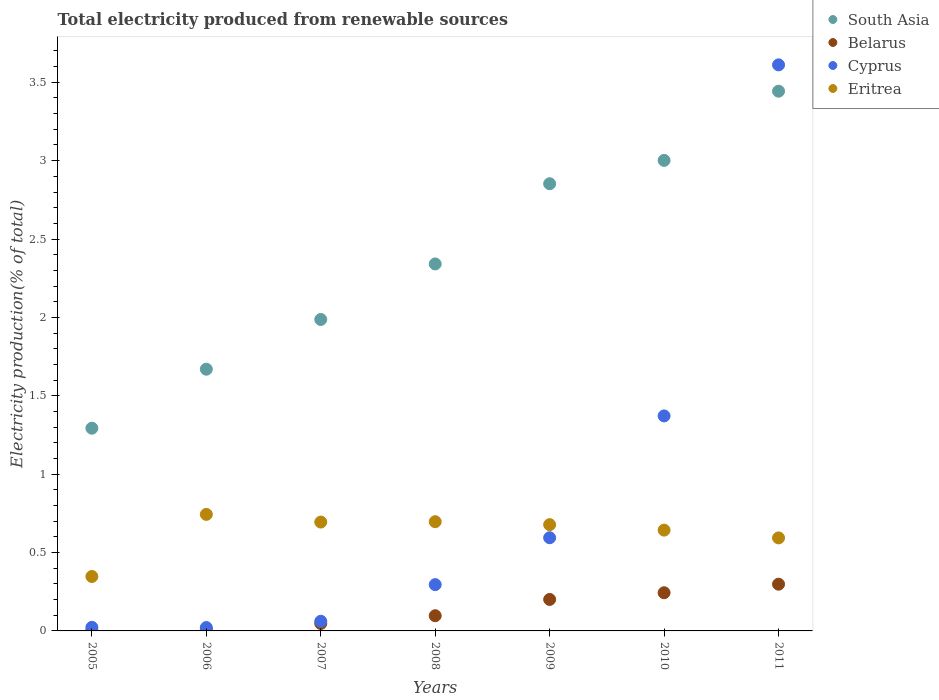How many different coloured dotlines are there?
Offer a terse response. 4. What is the total electricity produced in Eritrea in 2008?
Your answer should be compact. 0.7. Across all years, what is the maximum total electricity produced in Eritrea?
Your answer should be compact. 0.74. Across all years, what is the minimum total electricity produced in Cyprus?
Offer a very short reply. 0.02. In which year was the total electricity produced in South Asia minimum?
Your answer should be very brief. 2005. What is the total total electricity produced in Cyprus in the graph?
Provide a short and direct response. 5.98. What is the difference between the total electricity produced in Belarus in 2008 and that in 2010?
Provide a succinct answer. -0.15. What is the difference between the total electricity produced in Eritrea in 2006 and the total electricity produced in Belarus in 2005?
Your answer should be compact. 0.74. What is the average total electricity produced in Belarus per year?
Your response must be concise. 0.13. In the year 2007, what is the difference between the total electricity produced in Cyprus and total electricity produced in South Asia?
Keep it short and to the point. -1.93. What is the ratio of the total electricity produced in Cyprus in 2006 to that in 2011?
Make the answer very short. 0.01. What is the difference between the highest and the second highest total electricity produced in South Asia?
Give a very brief answer. 0.44. What is the difference between the highest and the lowest total electricity produced in South Asia?
Offer a terse response. 2.15. Does the total electricity produced in Belarus monotonically increase over the years?
Offer a terse response. Yes. Is the total electricity produced in Belarus strictly greater than the total electricity produced in Cyprus over the years?
Make the answer very short. No. How many dotlines are there?
Make the answer very short. 4. How many years are there in the graph?
Provide a succinct answer. 7. What is the title of the graph?
Offer a terse response. Total electricity produced from renewable sources. What is the label or title of the Y-axis?
Offer a very short reply. Electricity production(% of total). What is the Electricity production(% of total) in South Asia in 2005?
Your answer should be very brief. 1.29. What is the Electricity production(% of total) of Belarus in 2005?
Ensure brevity in your answer.  0. What is the Electricity production(% of total) in Cyprus in 2005?
Provide a short and direct response. 0.02. What is the Electricity production(% of total) of Eritrea in 2005?
Your answer should be very brief. 0.35. What is the Electricity production(% of total) in South Asia in 2006?
Offer a very short reply. 1.67. What is the Electricity production(% of total) in Belarus in 2006?
Your response must be concise. 0.01. What is the Electricity production(% of total) of Cyprus in 2006?
Provide a short and direct response. 0.02. What is the Electricity production(% of total) of Eritrea in 2006?
Offer a very short reply. 0.74. What is the Electricity production(% of total) in South Asia in 2007?
Offer a terse response. 1.99. What is the Electricity production(% of total) in Belarus in 2007?
Your answer should be very brief. 0.05. What is the Electricity production(% of total) of Cyprus in 2007?
Offer a terse response. 0.06. What is the Electricity production(% of total) of Eritrea in 2007?
Keep it short and to the point. 0.69. What is the Electricity production(% of total) in South Asia in 2008?
Offer a very short reply. 2.34. What is the Electricity production(% of total) in Belarus in 2008?
Provide a succinct answer. 0.1. What is the Electricity production(% of total) of Cyprus in 2008?
Ensure brevity in your answer.  0.3. What is the Electricity production(% of total) of Eritrea in 2008?
Your answer should be compact. 0.7. What is the Electricity production(% of total) in South Asia in 2009?
Ensure brevity in your answer.  2.85. What is the Electricity production(% of total) of Belarus in 2009?
Your answer should be very brief. 0.2. What is the Electricity production(% of total) of Cyprus in 2009?
Provide a succinct answer. 0.59. What is the Electricity production(% of total) of Eritrea in 2009?
Make the answer very short. 0.68. What is the Electricity production(% of total) in South Asia in 2010?
Your answer should be very brief. 3. What is the Electricity production(% of total) in Belarus in 2010?
Give a very brief answer. 0.24. What is the Electricity production(% of total) in Cyprus in 2010?
Give a very brief answer. 1.37. What is the Electricity production(% of total) in Eritrea in 2010?
Provide a succinct answer. 0.64. What is the Electricity production(% of total) of South Asia in 2011?
Ensure brevity in your answer.  3.44. What is the Electricity production(% of total) in Belarus in 2011?
Your answer should be very brief. 0.3. What is the Electricity production(% of total) of Cyprus in 2011?
Your answer should be very brief. 3.61. What is the Electricity production(% of total) of Eritrea in 2011?
Provide a succinct answer. 0.59. Across all years, what is the maximum Electricity production(% of total) of South Asia?
Make the answer very short. 3.44. Across all years, what is the maximum Electricity production(% of total) of Belarus?
Offer a very short reply. 0.3. Across all years, what is the maximum Electricity production(% of total) in Cyprus?
Your answer should be compact. 3.61. Across all years, what is the maximum Electricity production(% of total) in Eritrea?
Your answer should be compact. 0.74. Across all years, what is the minimum Electricity production(% of total) of South Asia?
Make the answer very short. 1.29. Across all years, what is the minimum Electricity production(% of total) of Belarus?
Ensure brevity in your answer.  0. Across all years, what is the minimum Electricity production(% of total) in Cyprus?
Your response must be concise. 0.02. Across all years, what is the minimum Electricity production(% of total) in Eritrea?
Offer a terse response. 0.35. What is the total Electricity production(% of total) in South Asia in the graph?
Ensure brevity in your answer.  16.59. What is the total Electricity production(% of total) in Belarus in the graph?
Your response must be concise. 0.9. What is the total Electricity production(% of total) of Cyprus in the graph?
Make the answer very short. 5.98. What is the total Electricity production(% of total) of Eritrea in the graph?
Ensure brevity in your answer.  4.4. What is the difference between the Electricity production(% of total) in South Asia in 2005 and that in 2006?
Make the answer very short. -0.38. What is the difference between the Electricity production(% of total) in Belarus in 2005 and that in 2006?
Offer a terse response. -0.01. What is the difference between the Electricity production(% of total) of Cyprus in 2005 and that in 2006?
Your response must be concise. 0. What is the difference between the Electricity production(% of total) of Eritrea in 2005 and that in 2006?
Keep it short and to the point. -0.4. What is the difference between the Electricity production(% of total) of South Asia in 2005 and that in 2007?
Your answer should be compact. -0.69. What is the difference between the Electricity production(% of total) in Belarus in 2005 and that in 2007?
Provide a short and direct response. -0.04. What is the difference between the Electricity production(% of total) in Cyprus in 2005 and that in 2007?
Ensure brevity in your answer.  -0.04. What is the difference between the Electricity production(% of total) of Eritrea in 2005 and that in 2007?
Provide a short and direct response. -0.35. What is the difference between the Electricity production(% of total) in South Asia in 2005 and that in 2008?
Offer a terse response. -1.05. What is the difference between the Electricity production(% of total) of Belarus in 2005 and that in 2008?
Ensure brevity in your answer.  -0.09. What is the difference between the Electricity production(% of total) of Cyprus in 2005 and that in 2008?
Offer a terse response. -0.27. What is the difference between the Electricity production(% of total) of Eritrea in 2005 and that in 2008?
Your answer should be compact. -0.35. What is the difference between the Electricity production(% of total) of South Asia in 2005 and that in 2009?
Make the answer very short. -1.56. What is the difference between the Electricity production(% of total) in Belarus in 2005 and that in 2009?
Give a very brief answer. -0.2. What is the difference between the Electricity production(% of total) in Cyprus in 2005 and that in 2009?
Offer a very short reply. -0.57. What is the difference between the Electricity production(% of total) in Eritrea in 2005 and that in 2009?
Provide a succinct answer. -0.33. What is the difference between the Electricity production(% of total) in South Asia in 2005 and that in 2010?
Keep it short and to the point. -1.71. What is the difference between the Electricity production(% of total) of Belarus in 2005 and that in 2010?
Ensure brevity in your answer.  -0.24. What is the difference between the Electricity production(% of total) of Cyprus in 2005 and that in 2010?
Provide a short and direct response. -1.35. What is the difference between the Electricity production(% of total) of Eritrea in 2005 and that in 2010?
Your answer should be very brief. -0.3. What is the difference between the Electricity production(% of total) of South Asia in 2005 and that in 2011?
Provide a succinct answer. -2.15. What is the difference between the Electricity production(% of total) in Belarus in 2005 and that in 2011?
Make the answer very short. -0.29. What is the difference between the Electricity production(% of total) of Cyprus in 2005 and that in 2011?
Your response must be concise. -3.59. What is the difference between the Electricity production(% of total) in Eritrea in 2005 and that in 2011?
Your answer should be compact. -0.25. What is the difference between the Electricity production(% of total) in South Asia in 2006 and that in 2007?
Offer a very short reply. -0.32. What is the difference between the Electricity production(% of total) in Belarus in 2006 and that in 2007?
Offer a very short reply. -0.04. What is the difference between the Electricity production(% of total) in Cyprus in 2006 and that in 2007?
Offer a terse response. -0.04. What is the difference between the Electricity production(% of total) of Eritrea in 2006 and that in 2007?
Ensure brevity in your answer.  0.05. What is the difference between the Electricity production(% of total) in South Asia in 2006 and that in 2008?
Provide a succinct answer. -0.67. What is the difference between the Electricity production(% of total) of Belarus in 2006 and that in 2008?
Make the answer very short. -0.09. What is the difference between the Electricity production(% of total) in Cyprus in 2006 and that in 2008?
Ensure brevity in your answer.  -0.27. What is the difference between the Electricity production(% of total) in Eritrea in 2006 and that in 2008?
Offer a very short reply. 0.05. What is the difference between the Electricity production(% of total) in South Asia in 2006 and that in 2009?
Ensure brevity in your answer.  -1.18. What is the difference between the Electricity production(% of total) in Belarus in 2006 and that in 2009?
Your response must be concise. -0.19. What is the difference between the Electricity production(% of total) of Cyprus in 2006 and that in 2009?
Your answer should be very brief. -0.57. What is the difference between the Electricity production(% of total) in Eritrea in 2006 and that in 2009?
Your response must be concise. 0.07. What is the difference between the Electricity production(% of total) of South Asia in 2006 and that in 2010?
Ensure brevity in your answer.  -1.33. What is the difference between the Electricity production(% of total) in Belarus in 2006 and that in 2010?
Offer a very short reply. -0.23. What is the difference between the Electricity production(% of total) in Cyprus in 2006 and that in 2010?
Your answer should be compact. -1.35. What is the difference between the Electricity production(% of total) of Eritrea in 2006 and that in 2010?
Provide a succinct answer. 0.1. What is the difference between the Electricity production(% of total) of South Asia in 2006 and that in 2011?
Keep it short and to the point. -1.77. What is the difference between the Electricity production(% of total) in Belarus in 2006 and that in 2011?
Offer a very short reply. -0.29. What is the difference between the Electricity production(% of total) of Cyprus in 2006 and that in 2011?
Offer a very short reply. -3.59. What is the difference between the Electricity production(% of total) in Eritrea in 2006 and that in 2011?
Your response must be concise. 0.15. What is the difference between the Electricity production(% of total) in South Asia in 2007 and that in 2008?
Make the answer very short. -0.35. What is the difference between the Electricity production(% of total) of Belarus in 2007 and that in 2008?
Give a very brief answer. -0.05. What is the difference between the Electricity production(% of total) of Cyprus in 2007 and that in 2008?
Your answer should be compact. -0.23. What is the difference between the Electricity production(% of total) in Eritrea in 2007 and that in 2008?
Your response must be concise. -0. What is the difference between the Electricity production(% of total) in South Asia in 2007 and that in 2009?
Offer a very short reply. -0.87. What is the difference between the Electricity production(% of total) of Belarus in 2007 and that in 2009?
Give a very brief answer. -0.15. What is the difference between the Electricity production(% of total) in Cyprus in 2007 and that in 2009?
Keep it short and to the point. -0.53. What is the difference between the Electricity production(% of total) in Eritrea in 2007 and that in 2009?
Provide a succinct answer. 0.02. What is the difference between the Electricity production(% of total) in South Asia in 2007 and that in 2010?
Your answer should be compact. -1.01. What is the difference between the Electricity production(% of total) of Belarus in 2007 and that in 2010?
Make the answer very short. -0.2. What is the difference between the Electricity production(% of total) in Cyprus in 2007 and that in 2010?
Your answer should be very brief. -1.31. What is the difference between the Electricity production(% of total) of Eritrea in 2007 and that in 2010?
Offer a very short reply. 0.05. What is the difference between the Electricity production(% of total) of South Asia in 2007 and that in 2011?
Offer a very short reply. -1.46. What is the difference between the Electricity production(% of total) in Belarus in 2007 and that in 2011?
Your response must be concise. -0.25. What is the difference between the Electricity production(% of total) in Cyprus in 2007 and that in 2011?
Make the answer very short. -3.55. What is the difference between the Electricity production(% of total) of Eritrea in 2007 and that in 2011?
Keep it short and to the point. 0.1. What is the difference between the Electricity production(% of total) in South Asia in 2008 and that in 2009?
Ensure brevity in your answer.  -0.51. What is the difference between the Electricity production(% of total) in Belarus in 2008 and that in 2009?
Your answer should be very brief. -0.1. What is the difference between the Electricity production(% of total) of Cyprus in 2008 and that in 2009?
Your answer should be compact. -0.3. What is the difference between the Electricity production(% of total) in Eritrea in 2008 and that in 2009?
Offer a terse response. 0.02. What is the difference between the Electricity production(% of total) of South Asia in 2008 and that in 2010?
Your answer should be compact. -0.66. What is the difference between the Electricity production(% of total) in Belarus in 2008 and that in 2010?
Your answer should be very brief. -0.15. What is the difference between the Electricity production(% of total) of Cyprus in 2008 and that in 2010?
Your answer should be very brief. -1.08. What is the difference between the Electricity production(% of total) in Eritrea in 2008 and that in 2010?
Make the answer very short. 0.05. What is the difference between the Electricity production(% of total) of South Asia in 2008 and that in 2011?
Provide a short and direct response. -1.1. What is the difference between the Electricity production(% of total) in Belarus in 2008 and that in 2011?
Make the answer very short. -0.2. What is the difference between the Electricity production(% of total) of Cyprus in 2008 and that in 2011?
Provide a short and direct response. -3.32. What is the difference between the Electricity production(% of total) of Eritrea in 2008 and that in 2011?
Your response must be concise. 0.1. What is the difference between the Electricity production(% of total) of South Asia in 2009 and that in 2010?
Provide a short and direct response. -0.15. What is the difference between the Electricity production(% of total) of Belarus in 2009 and that in 2010?
Provide a succinct answer. -0.04. What is the difference between the Electricity production(% of total) in Cyprus in 2009 and that in 2010?
Give a very brief answer. -0.78. What is the difference between the Electricity production(% of total) of Eritrea in 2009 and that in 2010?
Provide a succinct answer. 0.03. What is the difference between the Electricity production(% of total) of South Asia in 2009 and that in 2011?
Make the answer very short. -0.59. What is the difference between the Electricity production(% of total) in Belarus in 2009 and that in 2011?
Offer a terse response. -0.1. What is the difference between the Electricity production(% of total) of Cyprus in 2009 and that in 2011?
Give a very brief answer. -3.02. What is the difference between the Electricity production(% of total) in Eritrea in 2009 and that in 2011?
Give a very brief answer. 0.08. What is the difference between the Electricity production(% of total) of South Asia in 2010 and that in 2011?
Your answer should be very brief. -0.44. What is the difference between the Electricity production(% of total) in Belarus in 2010 and that in 2011?
Provide a succinct answer. -0.05. What is the difference between the Electricity production(% of total) of Cyprus in 2010 and that in 2011?
Your answer should be very brief. -2.24. What is the difference between the Electricity production(% of total) in Eritrea in 2010 and that in 2011?
Provide a short and direct response. 0.05. What is the difference between the Electricity production(% of total) in South Asia in 2005 and the Electricity production(% of total) in Belarus in 2006?
Keep it short and to the point. 1.28. What is the difference between the Electricity production(% of total) in South Asia in 2005 and the Electricity production(% of total) in Cyprus in 2006?
Provide a short and direct response. 1.27. What is the difference between the Electricity production(% of total) of South Asia in 2005 and the Electricity production(% of total) of Eritrea in 2006?
Keep it short and to the point. 0.55. What is the difference between the Electricity production(% of total) of Belarus in 2005 and the Electricity production(% of total) of Cyprus in 2006?
Keep it short and to the point. -0.02. What is the difference between the Electricity production(% of total) of Belarus in 2005 and the Electricity production(% of total) of Eritrea in 2006?
Ensure brevity in your answer.  -0.74. What is the difference between the Electricity production(% of total) of Cyprus in 2005 and the Electricity production(% of total) of Eritrea in 2006?
Provide a succinct answer. -0.72. What is the difference between the Electricity production(% of total) in South Asia in 2005 and the Electricity production(% of total) in Belarus in 2007?
Offer a terse response. 1.25. What is the difference between the Electricity production(% of total) of South Asia in 2005 and the Electricity production(% of total) of Cyprus in 2007?
Ensure brevity in your answer.  1.23. What is the difference between the Electricity production(% of total) in South Asia in 2005 and the Electricity production(% of total) in Eritrea in 2007?
Ensure brevity in your answer.  0.6. What is the difference between the Electricity production(% of total) in Belarus in 2005 and the Electricity production(% of total) in Cyprus in 2007?
Your answer should be compact. -0.06. What is the difference between the Electricity production(% of total) of Belarus in 2005 and the Electricity production(% of total) of Eritrea in 2007?
Ensure brevity in your answer.  -0.69. What is the difference between the Electricity production(% of total) of Cyprus in 2005 and the Electricity production(% of total) of Eritrea in 2007?
Your answer should be compact. -0.67. What is the difference between the Electricity production(% of total) of South Asia in 2005 and the Electricity production(% of total) of Belarus in 2008?
Your answer should be very brief. 1.2. What is the difference between the Electricity production(% of total) of South Asia in 2005 and the Electricity production(% of total) of Cyprus in 2008?
Your response must be concise. 1. What is the difference between the Electricity production(% of total) of South Asia in 2005 and the Electricity production(% of total) of Eritrea in 2008?
Keep it short and to the point. 0.6. What is the difference between the Electricity production(% of total) in Belarus in 2005 and the Electricity production(% of total) in Cyprus in 2008?
Keep it short and to the point. -0.29. What is the difference between the Electricity production(% of total) in Belarus in 2005 and the Electricity production(% of total) in Eritrea in 2008?
Ensure brevity in your answer.  -0.69. What is the difference between the Electricity production(% of total) in Cyprus in 2005 and the Electricity production(% of total) in Eritrea in 2008?
Ensure brevity in your answer.  -0.67. What is the difference between the Electricity production(% of total) in South Asia in 2005 and the Electricity production(% of total) in Belarus in 2009?
Provide a short and direct response. 1.09. What is the difference between the Electricity production(% of total) of South Asia in 2005 and the Electricity production(% of total) of Cyprus in 2009?
Keep it short and to the point. 0.7. What is the difference between the Electricity production(% of total) in South Asia in 2005 and the Electricity production(% of total) in Eritrea in 2009?
Give a very brief answer. 0.62. What is the difference between the Electricity production(% of total) of Belarus in 2005 and the Electricity production(% of total) of Cyprus in 2009?
Provide a short and direct response. -0.59. What is the difference between the Electricity production(% of total) of Belarus in 2005 and the Electricity production(% of total) of Eritrea in 2009?
Offer a very short reply. -0.67. What is the difference between the Electricity production(% of total) of Cyprus in 2005 and the Electricity production(% of total) of Eritrea in 2009?
Ensure brevity in your answer.  -0.66. What is the difference between the Electricity production(% of total) of South Asia in 2005 and the Electricity production(% of total) of Belarus in 2010?
Your response must be concise. 1.05. What is the difference between the Electricity production(% of total) of South Asia in 2005 and the Electricity production(% of total) of Cyprus in 2010?
Your response must be concise. -0.08. What is the difference between the Electricity production(% of total) of South Asia in 2005 and the Electricity production(% of total) of Eritrea in 2010?
Keep it short and to the point. 0.65. What is the difference between the Electricity production(% of total) of Belarus in 2005 and the Electricity production(% of total) of Cyprus in 2010?
Your answer should be very brief. -1.37. What is the difference between the Electricity production(% of total) of Belarus in 2005 and the Electricity production(% of total) of Eritrea in 2010?
Keep it short and to the point. -0.64. What is the difference between the Electricity production(% of total) of Cyprus in 2005 and the Electricity production(% of total) of Eritrea in 2010?
Make the answer very short. -0.62. What is the difference between the Electricity production(% of total) in South Asia in 2005 and the Electricity production(% of total) in Cyprus in 2011?
Your answer should be very brief. -2.32. What is the difference between the Electricity production(% of total) of South Asia in 2005 and the Electricity production(% of total) of Eritrea in 2011?
Keep it short and to the point. 0.7. What is the difference between the Electricity production(% of total) in Belarus in 2005 and the Electricity production(% of total) in Cyprus in 2011?
Keep it short and to the point. -3.61. What is the difference between the Electricity production(% of total) in Belarus in 2005 and the Electricity production(% of total) in Eritrea in 2011?
Give a very brief answer. -0.59. What is the difference between the Electricity production(% of total) of Cyprus in 2005 and the Electricity production(% of total) of Eritrea in 2011?
Ensure brevity in your answer.  -0.57. What is the difference between the Electricity production(% of total) in South Asia in 2006 and the Electricity production(% of total) in Belarus in 2007?
Ensure brevity in your answer.  1.62. What is the difference between the Electricity production(% of total) of South Asia in 2006 and the Electricity production(% of total) of Cyprus in 2007?
Make the answer very short. 1.61. What is the difference between the Electricity production(% of total) of South Asia in 2006 and the Electricity production(% of total) of Eritrea in 2007?
Offer a very short reply. 0.98. What is the difference between the Electricity production(% of total) of Belarus in 2006 and the Electricity production(% of total) of Cyprus in 2007?
Keep it short and to the point. -0.05. What is the difference between the Electricity production(% of total) in Belarus in 2006 and the Electricity production(% of total) in Eritrea in 2007?
Your response must be concise. -0.69. What is the difference between the Electricity production(% of total) of Cyprus in 2006 and the Electricity production(% of total) of Eritrea in 2007?
Your response must be concise. -0.67. What is the difference between the Electricity production(% of total) in South Asia in 2006 and the Electricity production(% of total) in Belarus in 2008?
Provide a short and direct response. 1.57. What is the difference between the Electricity production(% of total) in South Asia in 2006 and the Electricity production(% of total) in Cyprus in 2008?
Offer a terse response. 1.37. What is the difference between the Electricity production(% of total) in South Asia in 2006 and the Electricity production(% of total) in Eritrea in 2008?
Your response must be concise. 0.97. What is the difference between the Electricity production(% of total) of Belarus in 2006 and the Electricity production(% of total) of Cyprus in 2008?
Make the answer very short. -0.29. What is the difference between the Electricity production(% of total) in Belarus in 2006 and the Electricity production(% of total) in Eritrea in 2008?
Offer a very short reply. -0.69. What is the difference between the Electricity production(% of total) in Cyprus in 2006 and the Electricity production(% of total) in Eritrea in 2008?
Your response must be concise. -0.68. What is the difference between the Electricity production(% of total) in South Asia in 2006 and the Electricity production(% of total) in Belarus in 2009?
Offer a terse response. 1.47. What is the difference between the Electricity production(% of total) of South Asia in 2006 and the Electricity production(% of total) of Cyprus in 2009?
Provide a short and direct response. 1.08. What is the difference between the Electricity production(% of total) of Belarus in 2006 and the Electricity production(% of total) of Cyprus in 2009?
Ensure brevity in your answer.  -0.58. What is the difference between the Electricity production(% of total) in Belarus in 2006 and the Electricity production(% of total) in Eritrea in 2009?
Offer a terse response. -0.67. What is the difference between the Electricity production(% of total) in Cyprus in 2006 and the Electricity production(% of total) in Eritrea in 2009?
Give a very brief answer. -0.66. What is the difference between the Electricity production(% of total) of South Asia in 2006 and the Electricity production(% of total) of Belarus in 2010?
Provide a short and direct response. 1.43. What is the difference between the Electricity production(% of total) of South Asia in 2006 and the Electricity production(% of total) of Cyprus in 2010?
Ensure brevity in your answer.  0.3. What is the difference between the Electricity production(% of total) of South Asia in 2006 and the Electricity production(% of total) of Eritrea in 2010?
Keep it short and to the point. 1.03. What is the difference between the Electricity production(% of total) of Belarus in 2006 and the Electricity production(% of total) of Cyprus in 2010?
Ensure brevity in your answer.  -1.36. What is the difference between the Electricity production(% of total) in Belarus in 2006 and the Electricity production(% of total) in Eritrea in 2010?
Offer a terse response. -0.63. What is the difference between the Electricity production(% of total) in Cyprus in 2006 and the Electricity production(% of total) in Eritrea in 2010?
Your answer should be compact. -0.62. What is the difference between the Electricity production(% of total) in South Asia in 2006 and the Electricity production(% of total) in Belarus in 2011?
Keep it short and to the point. 1.37. What is the difference between the Electricity production(% of total) in South Asia in 2006 and the Electricity production(% of total) in Cyprus in 2011?
Your answer should be compact. -1.94. What is the difference between the Electricity production(% of total) of South Asia in 2006 and the Electricity production(% of total) of Eritrea in 2011?
Ensure brevity in your answer.  1.08. What is the difference between the Electricity production(% of total) in Belarus in 2006 and the Electricity production(% of total) in Cyprus in 2011?
Keep it short and to the point. -3.6. What is the difference between the Electricity production(% of total) in Belarus in 2006 and the Electricity production(% of total) in Eritrea in 2011?
Keep it short and to the point. -0.58. What is the difference between the Electricity production(% of total) in Cyprus in 2006 and the Electricity production(% of total) in Eritrea in 2011?
Make the answer very short. -0.57. What is the difference between the Electricity production(% of total) of South Asia in 2007 and the Electricity production(% of total) of Belarus in 2008?
Provide a succinct answer. 1.89. What is the difference between the Electricity production(% of total) in South Asia in 2007 and the Electricity production(% of total) in Cyprus in 2008?
Give a very brief answer. 1.69. What is the difference between the Electricity production(% of total) in South Asia in 2007 and the Electricity production(% of total) in Eritrea in 2008?
Provide a succinct answer. 1.29. What is the difference between the Electricity production(% of total) of Belarus in 2007 and the Electricity production(% of total) of Cyprus in 2008?
Offer a very short reply. -0.25. What is the difference between the Electricity production(% of total) in Belarus in 2007 and the Electricity production(% of total) in Eritrea in 2008?
Your answer should be compact. -0.65. What is the difference between the Electricity production(% of total) in Cyprus in 2007 and the Electricity production(% of total) in Eritrea in 2008?
Provide a short and direct response. -0.64. What is the difference between the Electricity production(% of total) of South Asia in 2007 and the Electricity production(% of total) of Belarus in 2009?
Your answer should be compact. 1.79. What is the difference between the Electricity production(% of total) of South Asia in 2007 and the Electricity production(% of total) of Cyprus in 2009?
Ensure brevity in your answer.  1.39. What is the difference between the Electricity production(% of total) of South Asia in 2007 and the Electricity production(% of total) of Eritrea in 2009?
Make the answer very short. 1.31. What is the difference between the Electricity production(% of total) in Belarus in 2007 and the Electricity production(% of total) in Cyprus in 2009?
Your response must be concise. -0.55. What is the difference between the Electricity production(% of total) of Belarus in 2007 and the Electricity production(% of total) of Eritrea in 2009?
Provide a short and direct response. -0.63. What is the difference between the Electricity production(% of total) in Cyprus in 2007 and the Electricity production(% of total) in Eritrea in 2009?
Offer a very short reply. -0.62. What is the difference between the Electricity production(% of total) of South Asia in 2007 and the Electricity production(% of total) of Belarus in 2010?
Give a very brief answer. 1.74. What is the difference between the Electricity production(% of total) in South Asia in 2007 and the Electricity production(% of total) in Cyprus in 2010?
Offer a terse response. 0.62. What is the difference between the Electricity production(% of total) in South Asia in 2007 and the Electricity production(% of total) in Eritrea in 2010?
Keep it short and to the point. 1.34. What is the difference between the Electricity production(% of total) in Belarus in 2007 and the Electricity production(% of total) in Cyprus in 2010?
Your response must be concise. -1.32. What is the difference between the Electricity production(% of total) in Belarus in 2007 and the Electricity production(% of total) in Eritrea in 2010?
Provide a succinct answer. -0.6. What is the difference between the Electricity production(% of total) of Cyprus in 2007 and the Electricity production(% of total) of Eritrea in 2010?
Ensure brevity in your answer.  -0.58. What is the difference between the Electricity production(% of total) of South Asia in 2007 and the Electricity production(% of total) of Belarus in 2011?
Give a very brief answer. 1.69. What is the difference between the Electricity production(% of total) in South Asia in 2007 and the Electricity production(% of total) in Cyprus in 2011?
Offer a terse response. -1.62. What is the difference between the Electricity production(% of total) in South Asia in 2007 and the Electricity production(% of total) in Eritrea in 2011?
Offer a very short reply. 1.39. What is the difference between the Electricity production(% of total) of Belarus in 2007 and the Electricity production(% of total) of Cyprus in 2011?
Ensure brevity in your answer.  -3.56. What is the difference between the Electricity production(% of total) of Belarus in 2007 and the Electricity production(% of total) of Eritrea in 2011?
Keep it short and to the point. -0.55. What is the difference between the Electricity production(% of total) in Cyprus in 2007 and the Electricity production(% of total) in Eritrea in 2011?
Offer a terse response. -0.53. What is the difference between the Electricity production(% of total) in South Asia in 2008 and the Electricity production(% of total) in Belarus in 2009?
Ensure brevity in your answer.  2.14. What is the difference between the Electricity production(% of total) of South Asia in 2008 and the Electricity production(% of total) of Cyprus in 2009?
Give a very brief answer. 1.75. What is the difference between the Electricity production(% of total) of South Asia in 2008 and the Electricity production(% of total) of Eritrea in 2009?
Your answer should be very brief. 1.66. What is the difference between the Electricity production(% of total) in Belarus in 2008 and the Electricity production(% of total) in Cyprus in 2009?
Your answer should be compact. -0.5. What is the difference between the Electricity production(% of total) in Belarus in 2008 and the Electricity production(% of total) in Eritrea in 2009?
Your answer should be compact. -0.58. What is the difference between the Electricity production(% of total) of Cyprus in 2008 and the Electricity production(% of total) of Eritrea in 2009?
Provide a succinct answer. -0.38. What is the difference between the Electricity production(% of total) in South Asia in 2008 and the Electricity production(% of total) in Belarus in 2010?
Offer a terse response. 2.1. What is the difference between the Electricity production(% of total) of South Asia in 2008 and the Electricity production(% of total) of Cyprus in 2010?
Give a very brief answer. 0.97. What is the difference between the Electricity production(% of total) of South Asia in 2008 and the Electricity production(% of total) of Eritrea in 2010?
Offer a very short reply. 1.7. What is the difference between the Electricity production(% of total) of Belarus in 2008 and the Electricity production(% of total) of Cyprus in 2010?
Your answer should be very brief. -1.27. What is the difference between the Electricity production(% of total) in Belarus in 2008 and the Electricity production(% of total) in Eritrea in 2010?
Keep it short and to the point. -0.55. What is the difference between the Electricity production(% of total) in Cyprus in 2008 and the Electricity production(% of total) in Eritrea in 2010?
Your answer should be very brief. -0.35. What is the difference between the Electricity production(% of total) in South Asia in 2008 and the Electricity production(% of total) in Belarus in 2011?
Offer a terse response. 2.04. What is the difference between the Electricity production(% of total) in South Asia in 2008 and the Electricity production(% of total) in Cyprus in 2011?
Provide a short and direct response. -1.27. What is the difference between the Electricity production(% of total) in South Asia in 2008 and the Electricity production(% of total) in Eritrea in 2011?
Offer a very short reply. 1.75. What is the difference between the Electricity production(% of total) in Belarus in 2008 and the Electricity production(% of total) in Cyprus in 2011?
Provide a succinct answer. -3.51. What is the difference between the Electricity production(% of total) in Belarus in 2008 and the Electricity production(% of total) in Eritrea in 2011?
Offer a terse response. -0.5. What is the difference between the Electricity production(% of total) in Cyprus in 2008 and the Electricity production(% of total) in Eritrea in 2011?
Offer a very short reply. -0.3. What is the difference between the Electricity production(% of total) of South Asia in 2009 and the Electricity production(% of total) of Belarus in 2010?
Give a very brief answer. 2.61. What is the difference between the Electricity production(% of total) of South Asia in 2009 and the Electricity production(% of total) of Cyprus in 2010?
Your answer should be very brief. 1.48. What is the difference between the Electricity production(% of total) in South Asia in 2009 and the Electricity production(% of total) in Eritrea in 2010?
Provide a short and direct response. 2.21. What is the difference between the Electricity production(% of total) of Belarus in 2009 and the Electricity production(% of total) of Cyprus in 2010?
Offer a very short reply. -1.17. What is the difference between the Electricity production(% of total) of Belarus in 2009 and the Electricity production(% of total) of Eritrea in 2010?
Make the answer very short. -0.44. What is the difference between the Electricity production(% of total) of Cyprus in 2009 and the Electricity production(% of total) of Eritrea in 2010?
Your answer should be very brief. -0.05. What is the difference between the Electricity production(% of total) in South Asia in 2009 and the Electricity production(% of total) in Belarus in 2011?
Your response must be concise. 2.55. What is the difference between the Electricity production(% of total) in South Asia in 2009 and the Electricity production(% of total) in Cyprus in 2011?
Make the answer very short. -0.76. What is the difference between the Electricity production(% of total) of South Asia in 2009 and the Electricity production(% of total) of Eritrea in 2011?
Offer a terse response. 2.26. What is the difference between the Electricity production(% of total) of Belarus in 2009 and the Electricity production(% of total) of Cyprus in 2011?
Make the answer very short. -3.41. What is the difference between the Electricity production(% of total) in Belarus in 2009 and the Electricity production(% of total) in Eritrea in 2011?
Ensure brevity in your answer.  -0.39. What is the difference between the Electricity production(% of total) of South Asia in 2010 and the Electricity production(% of total) of Belarus in 2011?
Offer a terse response. 2.7. What is the difference between the Electricity production(% of total) in South Asia in 2010 and the Electricity production(% of total) in Cyprus in 2011?
Your answer should be very brief. -0.61. What is the difference between the Electricity production(% of total) of South Asia in 2010 and the Electricity production(% of total) of Eritrea in 2011?
Your response must be concise. 2.41. What is the difference between the Electricity production(% of total) of Belarus in 2010 and the Electricity production(% of total) of Cyprus in 2011?
Offer a very short reply. -3.37. What is the difference between the Electricity production(% of total) of Belarus in 2010 and the Electricity production(% of total) of Eritrea in 2011?
Keep it short and to the point. -0.35. What is the difference between the Electricity production(% of total) in Cyprus in 2010 and the Electricity production(% of total) in Eritrea in 2011?
Offer a terse response. 0.78. What is the average Electricity production(% of total) in South Asia per year?
Keep it short and to the point. 2.37. What is the average Electricity production(% of total) of Belarus per year?
Offer a terse response. 0.13. What is the average Electricity production(% of total) of Cyprus per year?
Offer a terse response. 0.85. What is the average Electricity production(% of total) in Eritrea per year?
Ensure brevity in your answer.  0.63. In the year 2005, what is the difference between the Electricity production(% of total) in South Asia and Electricity production(% of total) in Belarus?
Provide a short and direct response. 1.29. In the year 2005, what is the difference between the Electricity production(% of total) of South Asia and Electricity production(% of total) of Cyprus?
Your answer should be compact. 1.27. In the year 2005, what is the difference between the Electricity production(% of total) of South Asia and Electricity production(% of total) of Eritrea?
Your answer should be very brief. 0.95. In the year 2005, what is the difference between the Electricity production(% of total) of Belarus and Electricity production(% of total) of Cyprus?
Ensure brevity in your answer.  -0.02. In the year 2005, what is the difference between the Electricity production(% of total) in Belarus and Electricity production(% of total) in Eritrea?
Your answer should be compact. -0.34. In the year 2005, what is the difference between the Electricity production(% of total) of Cyprus and Electricity production(% of total) of Eritrea?
Give a very brief answer. -0.32. In the year 2006, what is the difference between the Electricity production(% of total) of South Asia and Electricity production(% of total) of Belarus?
Give a very brief answer. 1.66. In the year 2006, what is the difference between the Electricity production(% of total) of South Asia and Electricity production(% of total) of Cyprus?
Make the answer very short. 1.65. In the year 2006, what is the difference between the Electricity production(% of total) of South Asia and Electricity production(% of total) of Eritrea?
Make the answer very short. 0.93. In the year 2006, what is the difference between the Electricity production(% of total) in Belarus and Electricity production(% of total) in Cyprus?
Make the answer very short. -0.01. In the year 2006, what is the difference between the Electricity production(% of total) of Belarus and Electricity production(% of total) of Eritrea?
Provide a succinct answer. -0.73. In the year 2006, what is the difference between the Electricity production(% of total) in Cyprus and Electricity production(% of total) in Eritrea?
Provide a succinct answer. -0.72. In the year 2007, what is the difference between the Electricity production(% of total) in South Asia and Electricity production(% of total) in Belarus?
Offer a terse response. 1.94. In the year 2007, what is the difference between the Electricity production(% of total) of South Asia and Electricity production(% of total) of Cyprus?
Make the answer very short. 1.93. In the year 2007, what is the difference between the Electricity production(% of total) of South Asia and Electricity production(% of total) of Eritrea?
Ensure brevity in your answer.  1.29. In the year 2007, what is the difference between the Electricity production(% of total) of Belarus and Electricity production(% of total) of Cyprus?
Ensure brevity in your answer.  -0.01. In the year 2007, what is the difference between the Electricity production(% of total) in Belarus and Electricity production(% of total) in Eritrea?
Keep it short and to the point. -0.65. In the year 2007, what is the difference between the Electricity production(% of total) in Cyprus and Electricity production(% of total) in Eritrea?
Make the answer very short. -0.63. In the year 2008, what is the difference between the Electricity production(% of total) in South Asia and Electricity production(% of total) in Belarus?
Keep it short and to the point. 2.24. In the year 2008, what is the difference between the Electricity production(% of total) of South Asia and Electricity production(% of total) of Cyprus?
Keep it short and to the point. 2.05. In the year 2008, what is the difference between the Electricity production(% of total) in South Asia and Electricity production(% of total) in Eritrea?
Keep it short and to the point. 1.64. In the year 2008, what is the difference between the Electricity production(% of total) in Belarus and Electricity production(% of total) in Cyprus?
Your response must be concise. -0.2. In the year 2008, what is the difference between the Electricity production(% of total) of Belarus and Electricity production(% of total) of Eritrea?
Your answer should be compact. -0.6. In the year 2008, what is the difference between the Electricity production(% of total) in Cyprus and Electricity production(% of total) in Eritrea?
Provide a short and direct response. -0.4. In the year 2009, what is the difference between the Electricity production(% of total) in South Asia and Electricity production(% of total) in Belarus?
Your answer should be compact. 2.65. In the year 2009, what is the difference between the Electricity production(% of total) of South Asia and Electricity production(% of total) of Cyprus?
Provide a succinct answer. 2.26. In the year 2009, what is the difference between the Electricity production(% of total) of South Asia and Electricity production(% of total) of Eritrea?
Offer a terse response. 2.17. In the year 2009, what is the difference between the Electricity production(% of total) in Belarus and Electricity production(% of total) in Cyprus?
Your answer should be compact. -0.39. In the year 2009, what is the difference between the Electricity production(% of total) of Belarus and Electricity production(% of total) of Eritrea?
Offer a terse response. -0.48. In the year 2009, what is the difference between the Electricity production(% of total) of Cyprus and Electricity production(% of total) of Eritrea?
Offer a very short reply. -0.08. In the year 2010, what is the difference between the Electricity production(% of total) of South Asia and Electricity production(% of total) of Belarus?
Make the answer very short. 2.76. In the year 2010, what is the difference between the Electricity production(% of total) in South Asia and Electricity production(% of total) in Cyprus?
Provide a short and direct response. 1.63. In the year 2010, what is the difference between the Electricity production(% of total) in South Asia and Electricity production(% of total) in Eritrea?
Offer a very short reply. 2.36. In the year 2010, what is the difference between the Electricity production(% of total) in Belarus and Electricity production(% of total) in Cyprus?
Your answer should be compact. -1.13. In the year 2010, what is the difference between the Electricity production(% of total) in Belarus and Electricity production(% of total) in Eritrea?
Ensure brevity in your answer.  -0.4. In the year 2010, what is the difference between the Electricity production(% of total) in Cyprus and Electricity production(% of total) in Eritrea?
Your answer should be compact. 0.73. In the year 2011, what is the difference between the Electricity production(% of total) in South Asia and Electricity production(% of total) in Belarus?
Offer a terse response. 3.15. In the year 2011, what is the difference between the Electricity production(% of total) in South Asia and Electricity production(% of total) in Cyprus?
Offer a terse response. -0.17. In the year 2011, what is the difference between the Electricity production(% of total) of South Asia and Electricity production(% of total) of Eritrea?
Provide a succinct answer. 2.85. In the year 2011, what is the difference between the Electricity production(% of total) in Belarus and Electricity production(% of total) in Cyprus?
Keep it short and to the point. -3.31. In the year 2011, what is the difference between the Electricity production(% of total) in Belarus and Electricity production(% of total) in Eritrea?
Keep it short and to the point. -0.3. In the year 2011, what is the difference between the Electricity production(% of total) in Cyprus and Electricity production(% of total) in Eritrea?
Offer a very short reply. 3.02. What is the ratio of the Electricity production(% of total) in South Asia in 2005 to that in 2006?
Offer a very short reply. 0.77. What is the ratio of the Electricity production(% of total) of Belarus in 2005 to that in 2006?
Keep it short and to the point. 0.34. What is the ratio of the Electricity production(% of total) in Cyprus in 2005 to that in 2006?
Offer a very short reply. 1.06. What is the ratio of the Electricity production(% of total) of Eritrea in 2005 to that in 2006?
Ensure brevity in your answer.  0.47. What is the ratio of the Electricity production(% of total) of South Asia in 2005 to that in 2007?
Provide a succinct answer. 0.65. What is the ratio of the Electricity production(% of total) in Belarus in 2005 to that in 2007?
Provide a short and direct response. 0.07. What is the ratio of the Electricity production(% of total) of Cyprus in 2005 to that in 2007?
Make the answer very short. 0.37. What is the ratio of the Electricity production(% of total) in South Asia in 2005 to that in 2008?
Make the answer very short. 0.55. What is the ratio of the Electricity production(% of total) of Cyprus in 2005 to that in 2008?
Your response must be concise. 0.08. What is the ratio of the Electricity production(% of total) in Eritrea in 2005 to that in 2008?
Your response must be concise. 0.5. What is the ratio of the Electricity production(% of total) of South Asia in 2005 to that in 2009?
Provide a short and direct response. 0.45. What is the ratio of the Electricity production(% of total) of Belarus in 2005 to that in 2009?
Your answer should be very brief. 0.02. What is the ratio of the Electricity production(% of total) in Cyprus in 2005 to that in 2009?
Make the answer very short. 0.04. What is the ratio of the Electricity production(% of total) of Eritrea in 2005 to that in 2009?
Your answer should be compact. 0.51. What is the ratio of the Electricity production(% of total) of South Asia in 2005 to that in 2010?
Offer a terse response. 0.43. What is the ratio of the Electricity production(% of total) in Belarus in 2005 to that in 2010?
Give a very brief answer. 0.01. What is the ratio of the Electricity production(% of total) of Cyprus in 2005 to that in 2010?
Offer a terse response. 0.02. What is the ratio of the Electricity production(% of total) of Eritrea in 2005 to that in 2010?
Your answer should be very brief. 0.54. What is the ratio of the Electricity production(% of total) of South Asia in 2005 to that in 2011?
Offer a terse response. 0.38. What is the ratio of the Electricity production(% of total) of Belarus in 2005 to that in 2011?
Your answer should be very brief. 0.01. What is the ratio of the Electricity production(% of total) of Cyprus in 2005 to that in 2011?
Your answer should be compact. 0.01. What is the ratio of the Electricity production(% of total) in Eritrea in 2005 to that in 2011?
Your response must be concise. 0.59. What is the ratio of the Electricity production(% of total) of South Asia in 2006 to that in 2007?
Offer a terse response. 0.84. What is the ratio of the Electricity production(% of total) of Belarus in 2006 to that in 2007?
Your answer should be very brief. 0.2. What is the ratio of the Electricity production(% of total) of Cyprus in 2006 to that in 2007?
Make the answer very short. 0.35. What is the ratio of the Electricity production(% of total) of Eritrea in 2006 to that in 2007?
Your response must be concise. 1.07. What is the ratio of the Electricity production(% of total) in South Asia in 2006 to that in 2008?
Your answer should be very brief. 0.71. What is the ratio of the Electricity production(% of total) of Belarus in 2006 to that in 2008?
Provide a short and direct response. 0.1. What is the ratio of the Electricity production(% of total) of Cyprus in 2006 to that in 2008?
Provide a short and direct response. 0.07. What is the ratio of the Electricity production(% of total) of Eritrea in 2006 to that in 2008?
Your answer should be very brief. 1.07. What is the ratio of the Electricity production(% of total) in South Asia in 2006 to that in 2009?
Make the answer very short. 0.59. What is the ratio of the Electricity production(% of total) in Belarus in 2006 to that in 2009?
Your answer should be very brief. 0.05. What is the ratio of the Electricity production(% of total) in Cyprus in 2006 to that in 2009?
Offer a very short reply. 0.04. What is the ratio of the Electricity production(% of total) in Eritrea in 2006 to that in 2009?
Provide a succinct answer. 1.1. What is the ratio of the Electricity production(% of total) of South Asia in 2006 to that in 2010?
Provide a short and direct response. 0.56. What is the ratio of the Electricity production(% of total) of Belarus in 2006 to that in 2010?
Offer a very short reply. 0.04. What is the ratio of the Electricity production(% of total) of Cyprus in 2006 to that in 2010?
Your answer should be very brief. 0.02. What is the ratio of the Electricity production(% of total) in Eritrea in 2006 to that in 2010?
Make the answer very short. 1.16. What is the ratio of the Electricity production(% of total) of South Asia in 2006 to that in 2011?
Make the answer very short. 0.48. What is the ratio of the Electricity production(% of total) in Belarus in 2006 to that in 2011?
Offer a very short reply. 0.03. What is the ratio of the Electricity production(% of total) of Cyprus in 2006 to that in 2011?
Ensure brevity in your answer.  0.01. What is the ratio of the Electricity production(% of total) in Eritrea in 2006 to that in 2011?
Your response must be concise. 1.25. What is the ratio of the Electricity production(% of total) in South Asia in 2007 to that in 2008?
Your answer should be compact. 0.85. What is the ratio of the Electricity production(% of total) in Belarus in 2007 to that in 2008?
Offer a very short reply. 0.49. What is the ratio of the Electricity production(% of total) in Cyprus in 2007 to that in 2008?
Ensure brevity in your answer.  0.21. What is the ratio of the Electricity production(% of total) in Eritrea in 2007 to that in 2008?
Provide a short and direct response. 1. What is the ratio of the Electricity production(% of total) in South Asia in 2007 to that in 2009?
Give a very brief answer. 0.7. What is the ratio of the Electricity production(% of total) in Belarus in 2007 to that in 2009?
Provide a short and direct response. 0.23. What is the ratio of the Electricity production(% of total) in Cyprus in 2007 to that in 2009?
Make the answer very short. 0.1. What is the ratio of the Electricity production(% of total) in Eritrea in 2007 to that in 2009?
Provide a short and direct response. 1.02. What is the ratio of the Electricity production(% of total) in South Asia in 2007 to that in 2010?
Give a very brief answer. 0.66. What is the ratio of the Electricity production(% of total) of Belarus in 2007 to that in 2010?
Provide a short and direct response. 0.19. What is the ratio of the Electricity production(% of total) in Cyprus in 2007 to that in 2010?
Provide a succinct answer. 0.04. What is the ratio of the Electricity production(% of total) in Eritrea in 2007 to that in 2010?
Offer a very short reply. 1.08. What is the ratio of the Electricity production(% of total) of South Asia in 2007 to that in 2011?
Your answer should be compact. 0.58. What is the ratio of the Electricity production(% of total) in Belarus in 2007 to that in 2011?
Keep it short and to the point. 0.16. What is the ratio of the Electricity production(% of total) of Cyprus in 2007 to that in 2011?
Your response must be concise. 0.02. What is the ratio of the Electricity production(% of total) of Eritrea in 2007 to that in 2011?
Offer a very short reply. 1.17. What is the ratio of the Electricity production(% of total) of South Asia in 2008 to that in 2009?
Give a very brief answer. 0.82. What is the ratio of the Electricity production(% of total) in Belarus in 2008 to that in 2009?
Your answer should be compact. 0.48. What is the ratio of the Electricity production(% of total) in Cyprus in 2008 to that in 2009?
Make the answer very short. 0.5. What is the ratio of the Electricity production(% of total) in Eritrea in 2008 to that in 2009?
Offer a terse response. 1.03. What is the ratio of the Electricity production(% of total) in South Asia in 2008 to that in 2010?
Make the answer very short. 0.78. What is the ratio of the Electricity production(% of total) in Belarus in 2008 to that in 2010?
Provide a succinct answer. 0.4. What is the ratio of the Electricity production(% of total) in Cyprus in 2008 to that in 2010?
Your answer should be compact. 0.22. What is the ratio of the Electricity production(% of total) in Eritrea in 2008 to that in 2010?
Give a very brief answer. 1.08. What is the ratio of the Electricity production(% of total) of South Asia in 2008 to that in 2011?
Offer a very short reply. 0.68. What is the ratio of the Electricity production(% of total) of Belarus in 2008 to that in 2011?
Your response must be concise. 0.33. What is the ratio of the Electricity production(% of total) in Cyprus in 2008 to that in 2011?
Your answer should be compact. 0.08. What is the ratio of the Electricity production(% of total) of Eritrea in 2008 to that in 2011?
Offer a terse response. 1.17. What is the ratio of the Electricity production(% of total) of South Asia in 2009 to that in 2010?
Give a very brief answer. 0.95. What is the ratio of the Electricity production(% of total) of Belarus in 2009 to that in 2010?
Provide a short and direct response. 0.82. What is the ratio of the Electricity production(% of total) of Cyprus in 2009 to that in 2010?
Make the answer very short. 0.43. What is the ratio of the Electricity production(% of total) of Eritrea in 2009 to that in 2010?
Ensure brevity in your answer.  1.05. What is the ratio of the Electricity production(% of total) of South Asia in 2009 to that in 2011?
Offer a very short reply. 0.83. What is the ratio of the Electricity production(% of total) of Belarus in 2009 to that in 2011?
Your answer should be very brief. 0.67. What is the ratio of the Electricity production(% of total) of Cyprus in 2009 to that in 2011?
Provide a succinct answer. 0.16. What is the ratio of the Electricity production(% of total) of Eritrea in 2009 to that in 2011?
Offer a terse response. 1.14. What is the ratio of the Electricity production(% of total) of South Asia in 2010 to that in 2011?
Offer a very short reply. 0.87. What is the ratio of the Electricity production(% of total) of Belarus in 2010 to that in 2011?
Ensure brevity in your answer.  0.82. What is the ratio of the Electricity production(% of total) of Cyprus in 2010 to that in 2011?
Provide a succinct answer. 0.38. What is the ratio of the Electricity production(% of total) of Eritrea in 2010 to that in 2011?
Offer a terse response. 1.08. What is the difference between the highest and the second highest Electricity production(% of total) of South Asia?
Give a very brief answer. 0.44. What is the difference between the highest and the second highest Electricity production(% of total) of Belarus?
Your response must be concise. 0.05. What is the difference between the highest and the second highest Electricity production(% of total) in Cyprus?
Make the answer very short. 2.24. What is the difference between the highest and the second highest Electricity production(% of total) in Eritrea?
Provide a succinct answer. 0.05. What is the difference between the highest and the lowest Electricity production(% of total) in South Asia?
Your response must be concise. 2.15. What is the difference between the highest and the lowest Electricity production(% of total) in Belarus?
Keep it short and to the point. 0.29. What is the difference between the highest and the lowest Electricity production(% of total) of Cyprus?
Keep it short and to the point. 3.59. What is the difference between the highest and the lowest Electricity production(% of total) of Eritrea?
Provide a succinct answer. 0.4. 